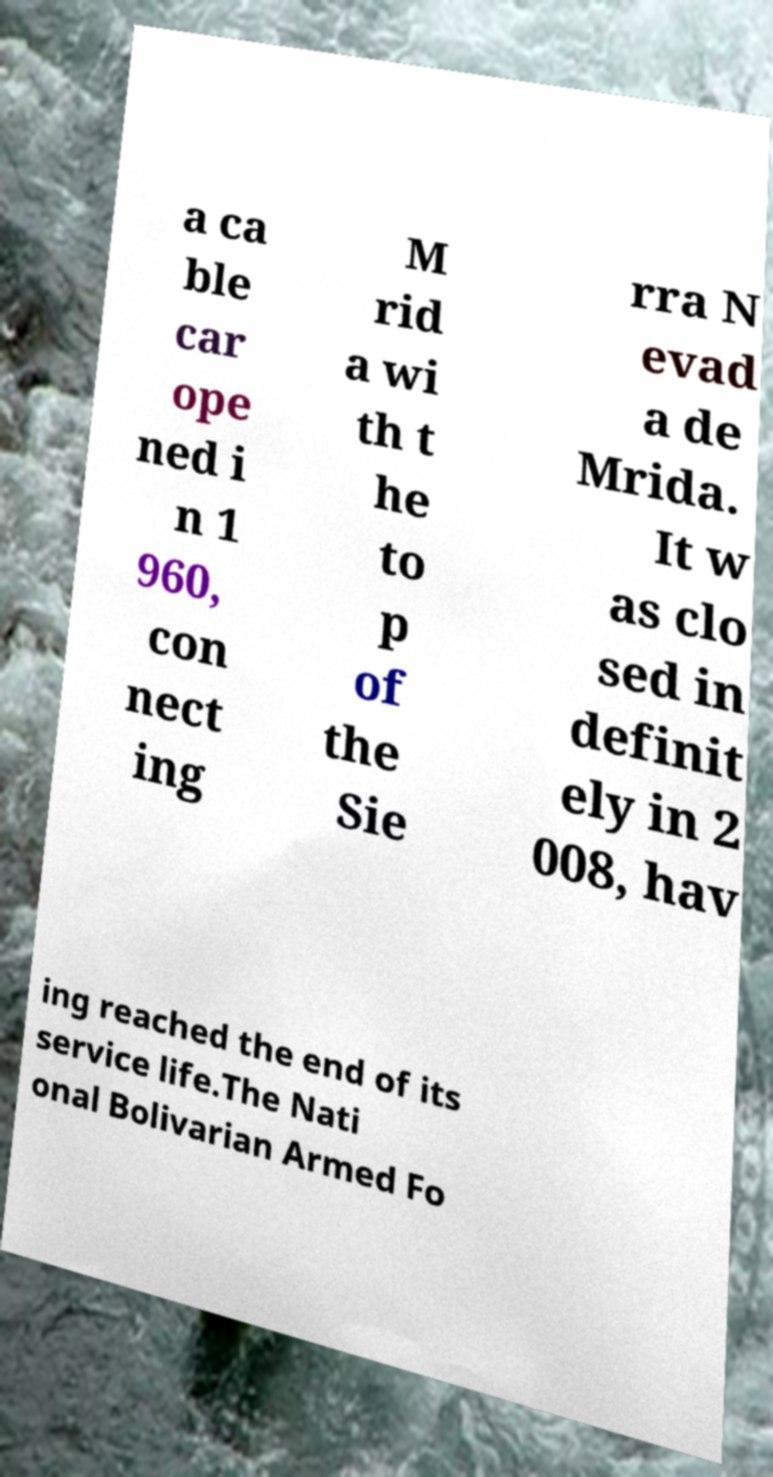Can you read and provide the text displayed in the image?This photo seems to have some interesting text. Can you extract and type it out for me? a ca ble car ope ned i n 1 960, con nect ing M rid a wi th t he to p of the Sie rra N evad a de Mrida. It w as clo sed in definit ely in 2 008, hav ing reached the end of its service life.The Nati onal Bolivarian Armed Fo 